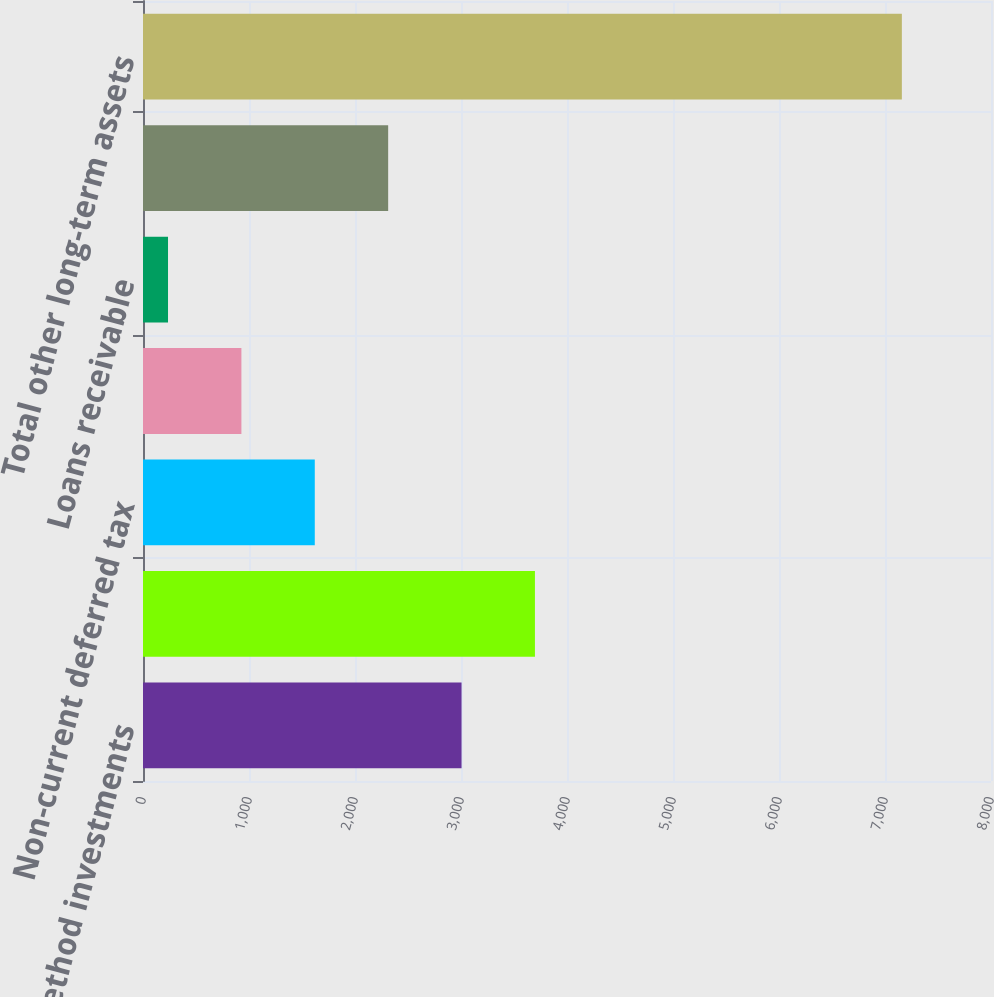Convert chart to OTSL. <chart><loc_0><loc_0><loc_500><loc_500><bar_chart><fcel>Equity method investments<fcel>Non-marketable cost method<fcel>Non-current deferred tax<fcel>Pre-payments for property<fcel>Loans receivable<fcel>Other<fcel>Total other long-term assets<nl><fcel>3005.2<fcel>3697.5<fcel>1620.6<fcel>928.3<fcel>236<fcel>2312.9<fcel>7159<nl></chart> 